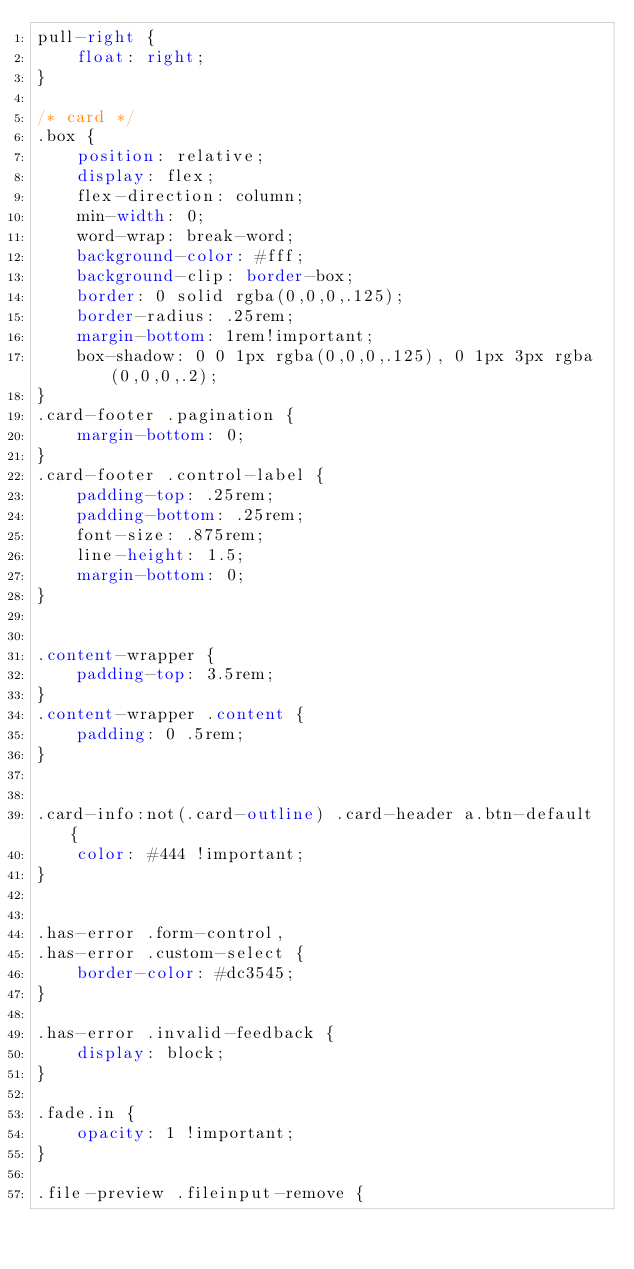<code> <loc_0><loc_0><loc_500><loc_500><_CSS_>pull-right {
    float: right;
}

/* card */
.box {
    position: relative;
    display: flex;
    flex-direction: column;
    min-width: 0;
    word-wrap: break-word;
    background-color: #fff;
    background-clip: border-box;
    border: 0 solid rgba(0,0,0,.125);
    border-radius: .25rem;
    margin-bottom: 1rem!important;
    box-shadow: 0 0 1px rgba(0,0,0,.125), 0 1px 3px rgba(0,0,0,.2);
}
.card-footer .pagination {
    margin-bottom: 0;
}
.card-footer .control-label {
    padding-top: .25rem;
    padding-bottom: .25rem;
    font-size: .875rem;
    line-height: 1.5;
    margin-bottom: 0;
}


.content-wrapper {
    padding-top: 3.5rem;
}
.content-wrapper .content {
    padding: 0 .5rem;
}


.card-info:not(.card-outline) .card-header a.btn-default {
    color: #444 !important;
}


.has-error .form-control,
.has-error .custom-select {
    border-color: #dc3545;
}

.has-error .invalid-feedback {
    display: block;
}

.fade.in {
    opacity: 1 !important;
}

.file-preview .fileinput-remove {</code> 